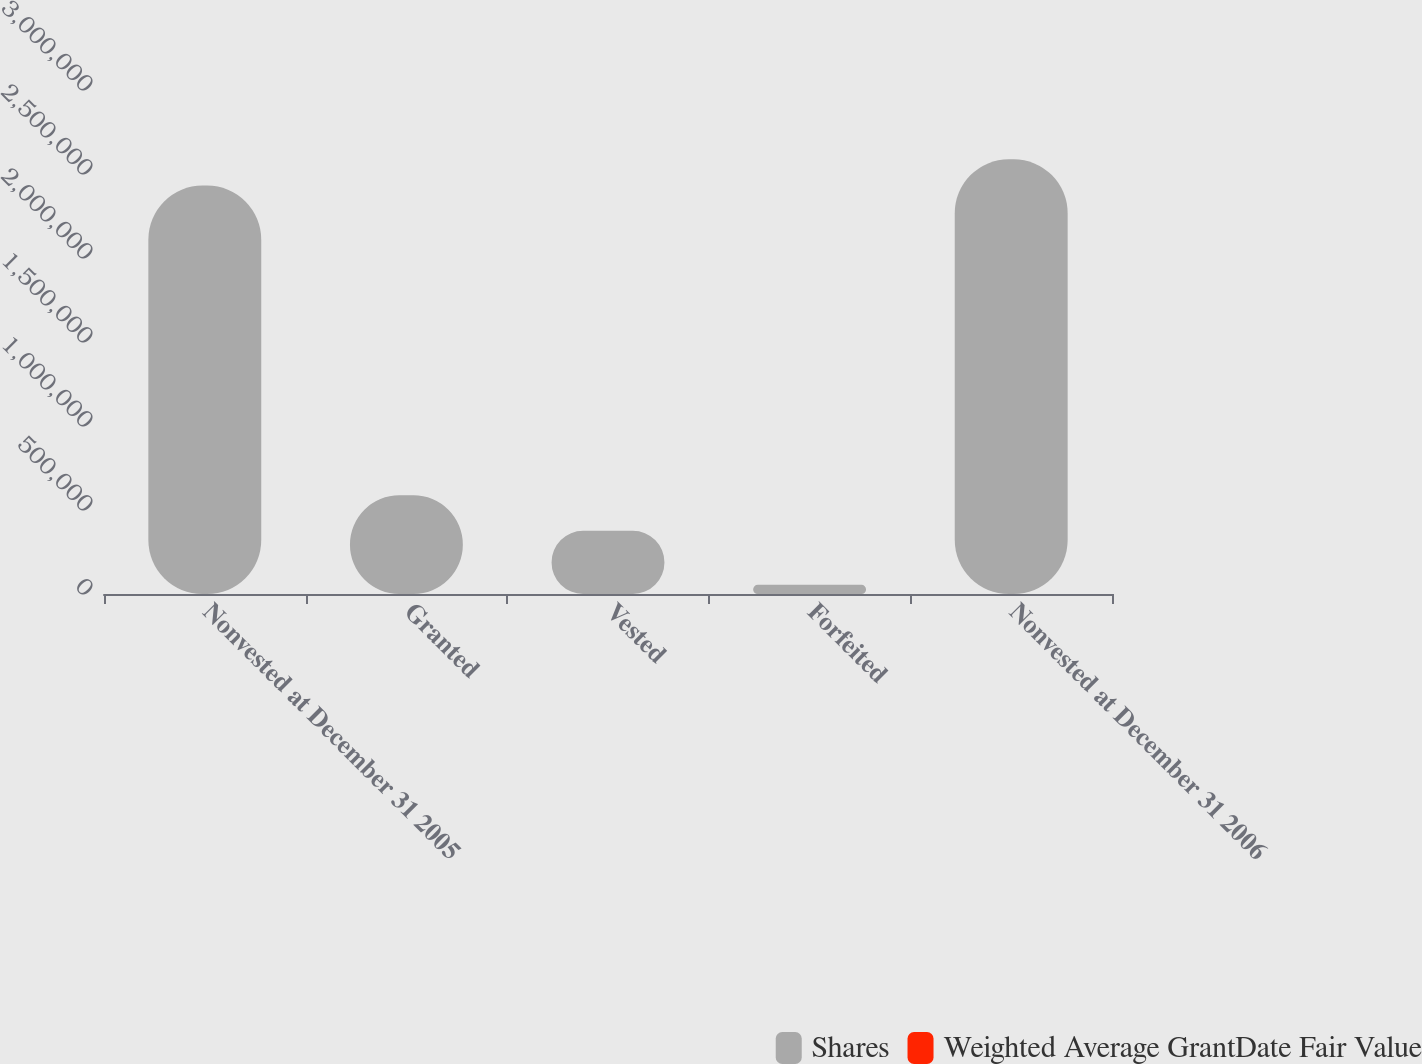Convert chart. <chart><loc_0><loc_0><loc_500><loc_500><stacked_bar_chart><ecel><fcel>Nonvested at December 31 2005<fcel>Granted<fcel>Vested<fcel>Forfeited<fcel>Nonvested at December 31 2006<nl><fcel>Shares<fcel>2.43119e+06<fcel>587108<fcel>375852<fcel>54789<fcel>2.58766e+06<nl><fcel>Weighted Average GrantDate Fair Value<fcel>51.8<fcel>61.52<fcel>44.84<fcel>55.98<fcel>54.93<nl></chart> 